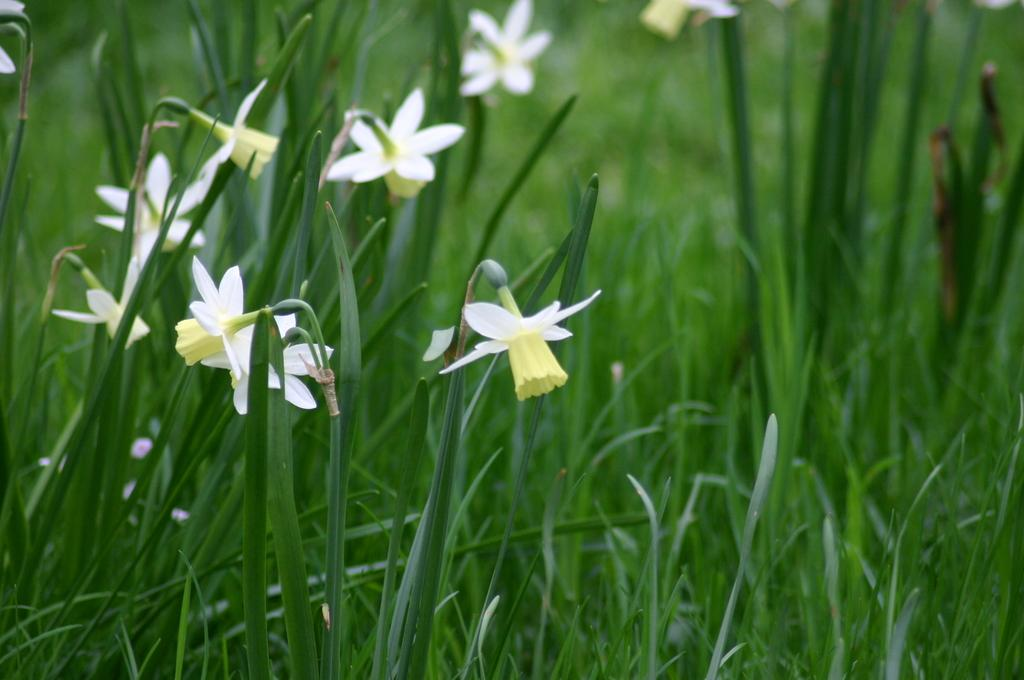What is the main subject of the image? The main subject of the image is a group of flowers. What else can be seen in the image besides the flowers? There are leaves in the image. Can you see a basketball being played with in the image? There is no basketball or any indication of a game being played in the image. What type of box is present in the image? There is no box present in the image; it features a group of flowers and leaves. 